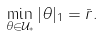Convert formula to latex. <formula><loc_0><loc_0><loc_500><loc_500>\min _ { \theta \in { \mathcal { U } } _ { * } } | \theta | _ { 1 } = \bar { r } .</formula> 